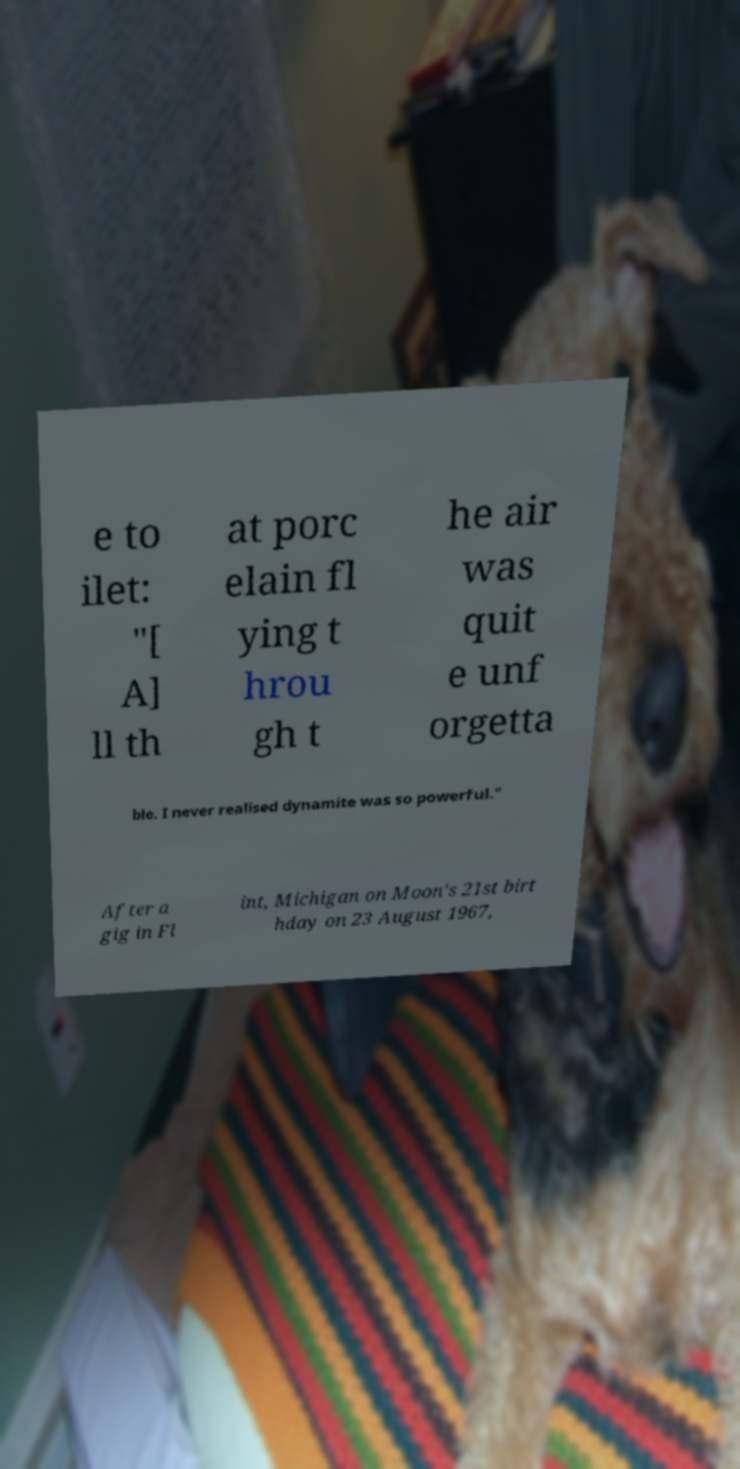Please identify and transcribe the text found in this image. e to ilet: "[ A] ll th at porc elain fl ying t hrou gh t he air was quit e unf orgetta ble. I never realised dynamite was so powerful." After a gig in Fl int, Michigan on Moon's 21st birt hday on 23 August 1967, 